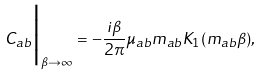Convert formula to latex. <formula><loc_0><loc_0><loc_500><loc_500>C _ { a b } \Big | _ { \beta \rightarrow \infty } = - \frac { i \beta } { 2 \pi } \mu _ { a b } m _ { a b } K _ { 1 } ( m _ { a b } \beta ) ,</formula> 